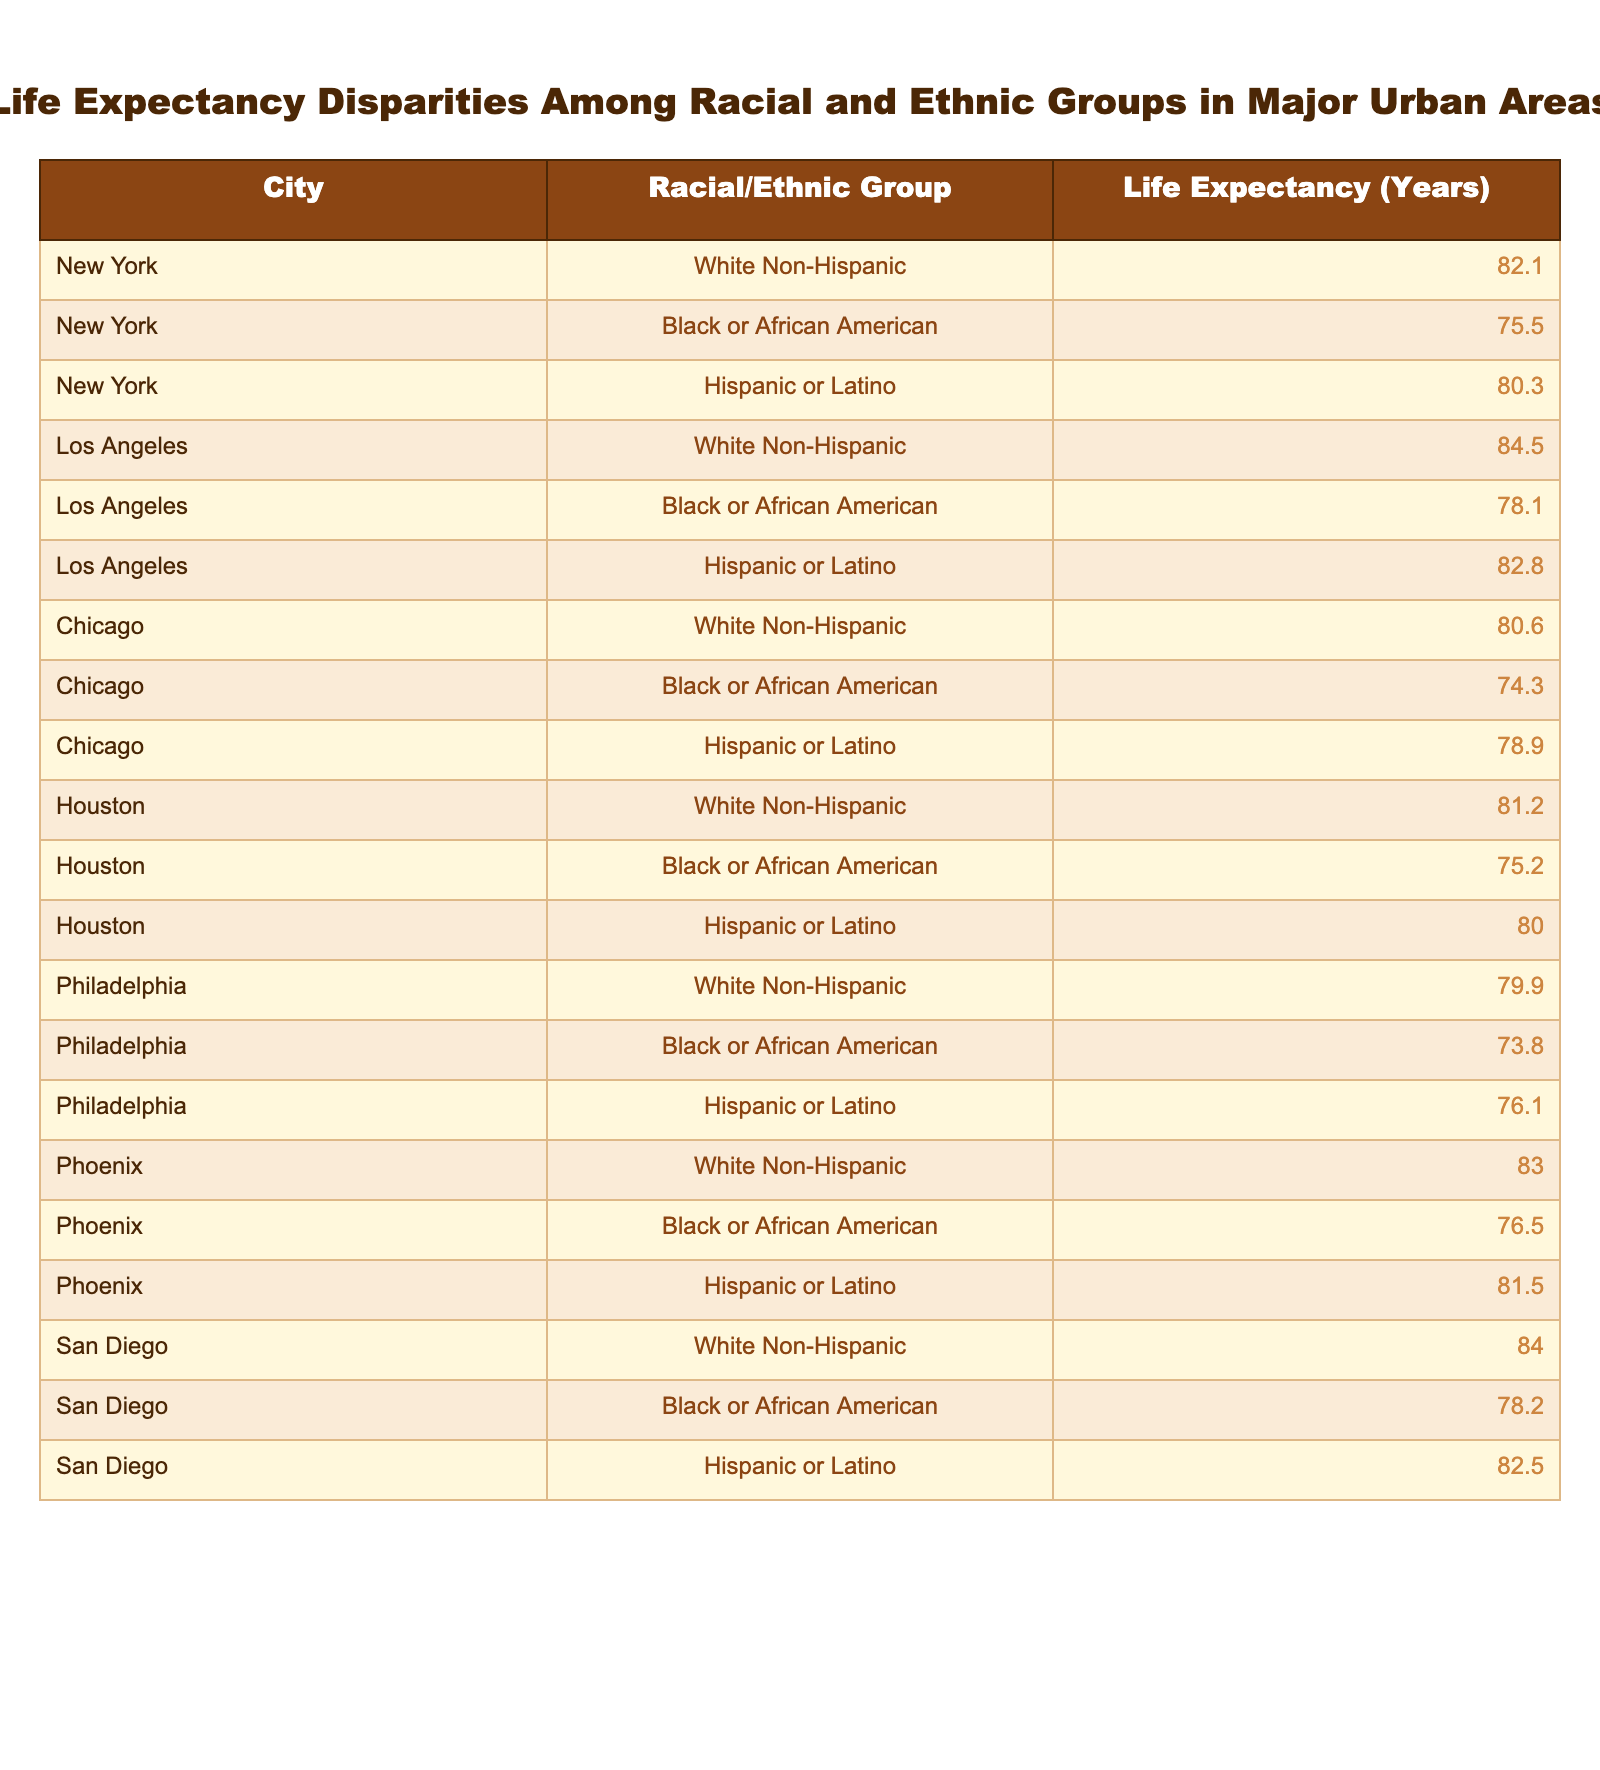What is the life expectancy of Black or African American individuals in New York? According to the table, the life expectancy for Black or African American individuals in New York is specifically listed as 75.5 years.
Answer: 75.5 Which city has the highest life expectancy for Hispanic or Latino individuals? The table shows that the highest life expectancy for Hispanic or Latino individuals is in Los Angeles at 82.8 years.
Answer: 82.8 Is the life expectancy for Black or African American individuals higher in Los Angeles or Chicago? The life expectancy for Black or African American individuals in Los Angeles is 78.1 years, while in Chicago it is 74.3 years. Thus, it is higher in Los Angeles.
Answer: Yes What is the average life expectancy for White Non-Hispanic individuals across all listed cities? The life expectancy values for White Non-Hispanic individuals are 82.1 (New York), 84.5 (Los Angeles), 80.6 (Chicago), 81.2 (Houston), 79.9 (Philadelphia), 83.0 (Phoenix), and 84.0 (San Diego). Adding these values (82.1 + 84.5 + 80.6 + 81.2 + 79.9 + 83.0 + 84.0) gives a total of  575.3 and then dividing by 7 (the number of data points) results in an average of approximately 82.19 years.
Answer: 82.19 Which city shows the least disparity in life expectancy between White Non-Hispanic and Black or African American groups? To evaluate the disparity, we look at the differences: in New York, it's 6.6 years; in Los Angeles, 6.4 years; in Chicago, 6.3 years; in Houston, 6.0 years; in Philadelphia, 6.1 years; in Phoenix, 6.5 years; and in San Diego, 5.8 years. The least disparity is in San Diego with a difference of 5.8 years.
Answer: San Diego What percentage difference in life expectancy is there between Hispanic or Latino individuals in Chicago and Los Angeles? The life expectancy for Hispanic or Latino individuals in Chicago is 78.9 years and in Los Angeles it is 82.8 years. The difference is 82.8 - 78.9 = 3.9 years. To find the percentage difference, we take 3.9 / 78.9 * 100, which equals approximately 4.94 percent.
Answer: 4.94% Is it true that the life expectancy for Hispanic or Latino individuals is higher than that for Black or African American individuals in all listed cities? Referring to the data, we see that in New York (80.3 vs 75.5), Los Angeles (82.8 vs 78.1), Chicago (78.9 vs 74.3), and Houston (80.0 vs 75.2) this is true, as well as in Philadelphia (76.1 vs 73.8), Phoenix (81.5 vs 76.5), and San Diego (82.5 vs 78.2). Thus, the statement is true for all cities.
Answer: Yes What is the overall trend in life expectancy for Black or African American individuals across the listed cities? Observing the life expectancy values for Black or African American individuals: New York (75.5), Los Angeles (78.1), Chicago (74.3), Houston (75.2), Philadelphia (73.8), Phoenix (76.5), and San Diego (78.2), it appears that there is an upward trend as we move from New York and Chicago towards San Diego and Los Angeles.
Answer: Upward trend 